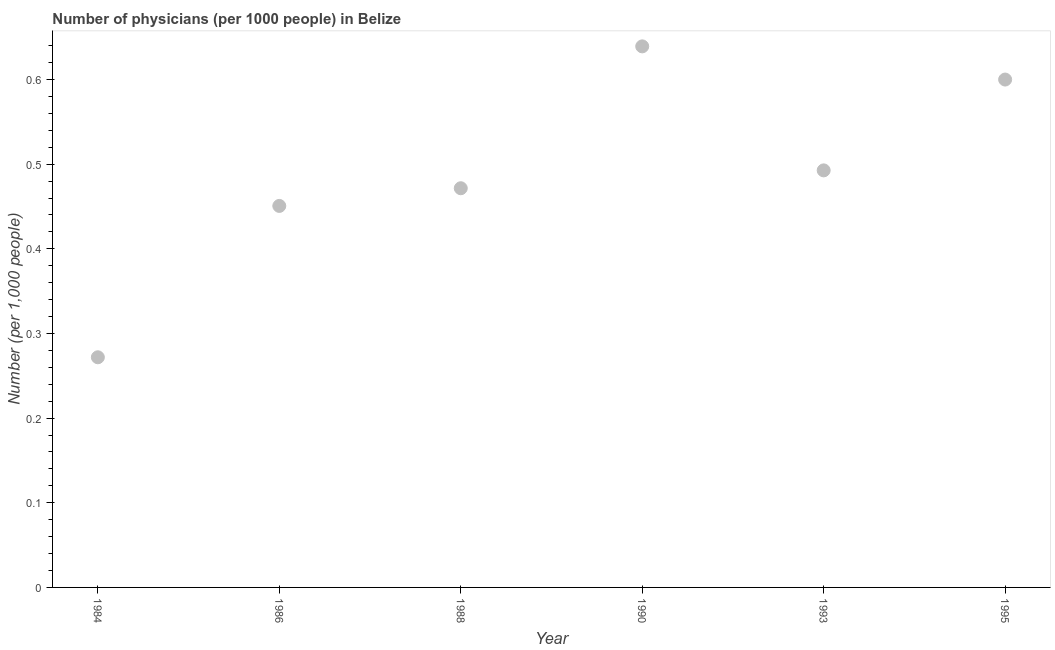What is the number of physicians in 1988?
Provide a short and direct response. 0.47. Across all years, what is the maximum number of physicians?
Give a very brief answer. 0.64. Across all years, what is the minimum number of physicians?
Ensure brevity in your answer.  0.27. In which year was the number of physicians maximum?
Offer a very short reply. 1990. In which year was the number of physicians minimum?
Keep it short and to the point. 1984. What is the sum of the number of physicians?
Provide a short and direct response. 2.93. What is the difference between the number of physicians in 1988 and 1995?
Ensure brevity in your answer.  -0.13. What is the average number of physicians per year?
Keep it short and to the point. 0.49. What is the median number of physicians?
Provide a succinct answer. 0.48. In how many years, is the number of physicians greater than 0.30000000000000004 ?
Keep it short and to the point. 5. Do a majority of the years between 1990 and 1984 (inclusive) have number of physicians greater than 0.26 ?
Your answer should be compact. Yes. What is the ratio of the number of physicians in 1990 to that in 1995?
Ensure brevity in your answer.  1.07. Is the number of physicians in 1986 less than that in 1990?
Offer a terse response. Yes. Is the difference between the number of physicians in 1984 and 1990 greater than the difference between any two years?
Offer a very short reply. Yes. What is the difference between the highest and the second highest number of physicians?
Offer a terse response. 0.04. What is the difference between the highest and the lowest number of physicians?
Your answer should be very brief. 0.37. How many dotlines are there?
Provide a short and direct response. 1. What is the difference between two consecutive major ticks on the Y-axis?
Your answer should be compact. 0.1. Are the values on the major ticks of Y-axis written in scientific E-notation?
Give a very brief answer. No. Does the graph contain any zero values?
Provide a short and direct response. No. Does the graph contain grids?
Make the answer very short. No. What is the title of the graph?
Offer a very short reply. Number of physicians (per 1000 people) in Belize. What is the label or title of the X-axis?
Your response must be concise. Year. What is the label or title of the Y-axis?
Your answer should be compact. Number (per 1,0 people). What is the Number (per 1,000 people) in 1984?
Make the answer very short. 0.27. What is the Number (per 1,000 people) in 1986?
Your answer should be very brief. 0.45. What is the Number (per 1,000 people) in 1988?
Give a very brief answer. 0.47. What is the Number (per 1,000 people) in 1990?
Offer a very short reply. 0.64. What is the Number (per 1,000 people) in 1993?
Your response must be concise. 0.49. What is the difference between the Number (per 1,000 people) in 1984 and 1986?
Your answer should be compact. -0.18. What is the difference between the Number (per 1,000 people) in 1984 and 1988?
Offer a terse response. -0.2. What is the difference between the Number (per 1,000 people) in 1984 and 1990?
Make the answer very short. -0.37. What is the difference between the Number (per 1,000 people) in 1984 and 1993?
Your answer should be compact. -0.22. What is the difference between the Number (per 1,000 people) in 1984 and 1995?
Offer a very short reply. -0.33. What is the difference between the Number (per 1,000 people) in 1986 and 1988?
Provide a short and direct response. -0.02. What is the difference between the Number (per 1,000 people) in 1986 and 1990?
Provide a succinct answer. -0.19. What is the difference between the Number (per 1,000 people) in 1986 and 1993?
Give a very brief answer. -0.04. What is the difference between the Number (per 1,000 people) in 1986 and 1995?
Make the answer very short. -0.15. What is the difference between the Number (per 1,000 people) in 1988 and 1990?
Provide a succinct answer. -0.17. What is the difference between the Number (per 1,000 people) in 1988 and 1993?
Your answer should be very brief. -0.02. What is the difference between the Number (per 1,000 people) in 1988 and 1995?
Your answer should be very brief. -0.13. What is the difference between the Number (per 1,000 people) in 1990 and 1993?
Give a very brief answer. 0.15. What is the difference between the Number (per 1,000 people) in 1990 and 1995?
Your answer should be compact. 0.04. What is the difference between the Number (per 1,000 people) in 1993 and 1995?
Your answer should be compact. -0.11. What is the ratio of the Number (per 1,000 people) in 1984 to that in 1986?
Give a very brief answer. 0.6. What is the ratio of the Number (per 1,000 people) in 1984 to that in 1988?
Offer a very short reply. 0.58. What is the ratio of the Number (per 1,000 people) in 1984 to that in 1990?
Offer a very short reply. 0.42. What is the ratio of the Number (per 1,000 people) in 1984 to that in 1993?
Make the answer very short. 0.55. What is the ratio of the Number (per 1,000 people) in 1984 to that in 1995?
Make the answer very short. 0.45. What is the ratio of the Number (per 1,000 people) in 1986 to that in 1988?
Your response must be concise. 0.96. What is the ratio of the Number (per 1,000 people) in 1986 to that in 1990?
Your answer should be very brief. 0.7. What is the ratio of the Number (per 1,000 people) in 1986 to that in 1993?
Your response must be concise. 0.92. What is the ratio of the Number (per 1,000 people) in 1986 to that in 1995?
Offer a terse response. 0.75. What is the ratio of the Number (per 1,000 people) in 1988 to that in 1990?
Provide a succinct answer. 0.74. What is the ratio of the Number (per 1,000 people) in 1988 to that in 1995?
Offer a terse response. 0.79. What is the ratio of the Number (per 1,000 people) in 1990 to that in 1993?
Your response must be concise. 1.3. What is the ratio of the Number (per 1,000 people) in 1990 to that in 1995?
Ensure brevity in your answer.  1.06. What is the ratio of the Number (per 1,000 people) in 1993 to that in 1995?
Provide a short and direct response. 0.82. 